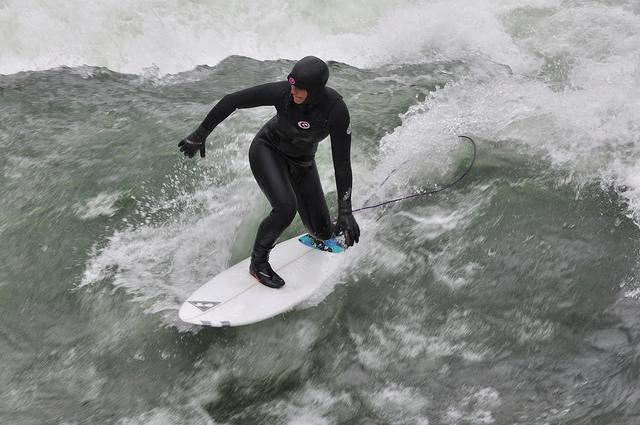How many solid black cats on the chair?
Give a very brief answer. 0. 